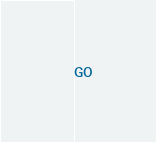<code> <loc_0><loc_0><loc_500><loc_500><_SQL_>GO

</code> 